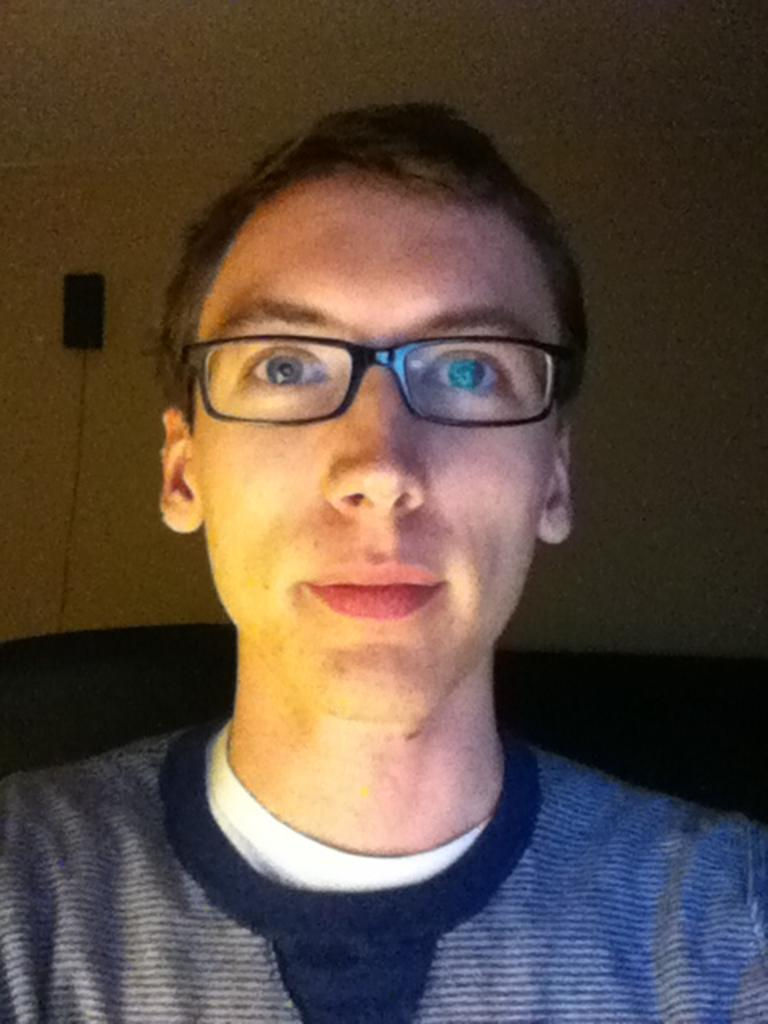Who is present in the image? There is a man in the image. What is the man wearing? The man is wearing spectacles. What can be seen behind the man? There is a wall behind the man. What is on the wall to the left? There is an object on the wall to the left. What type of engine is powering the magic in the image? There is no engine or magic present in the image; it features a man standing in front of a wall with an object on it. 